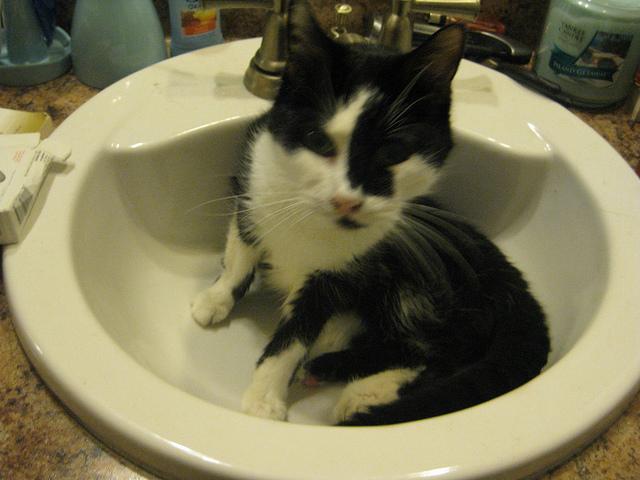Where is this cat lying?
Give a very brief answer. Sink. Is this photo in a bathroom?
Be succinct. Yes. What color is the sink?
Quick response, please. White. 